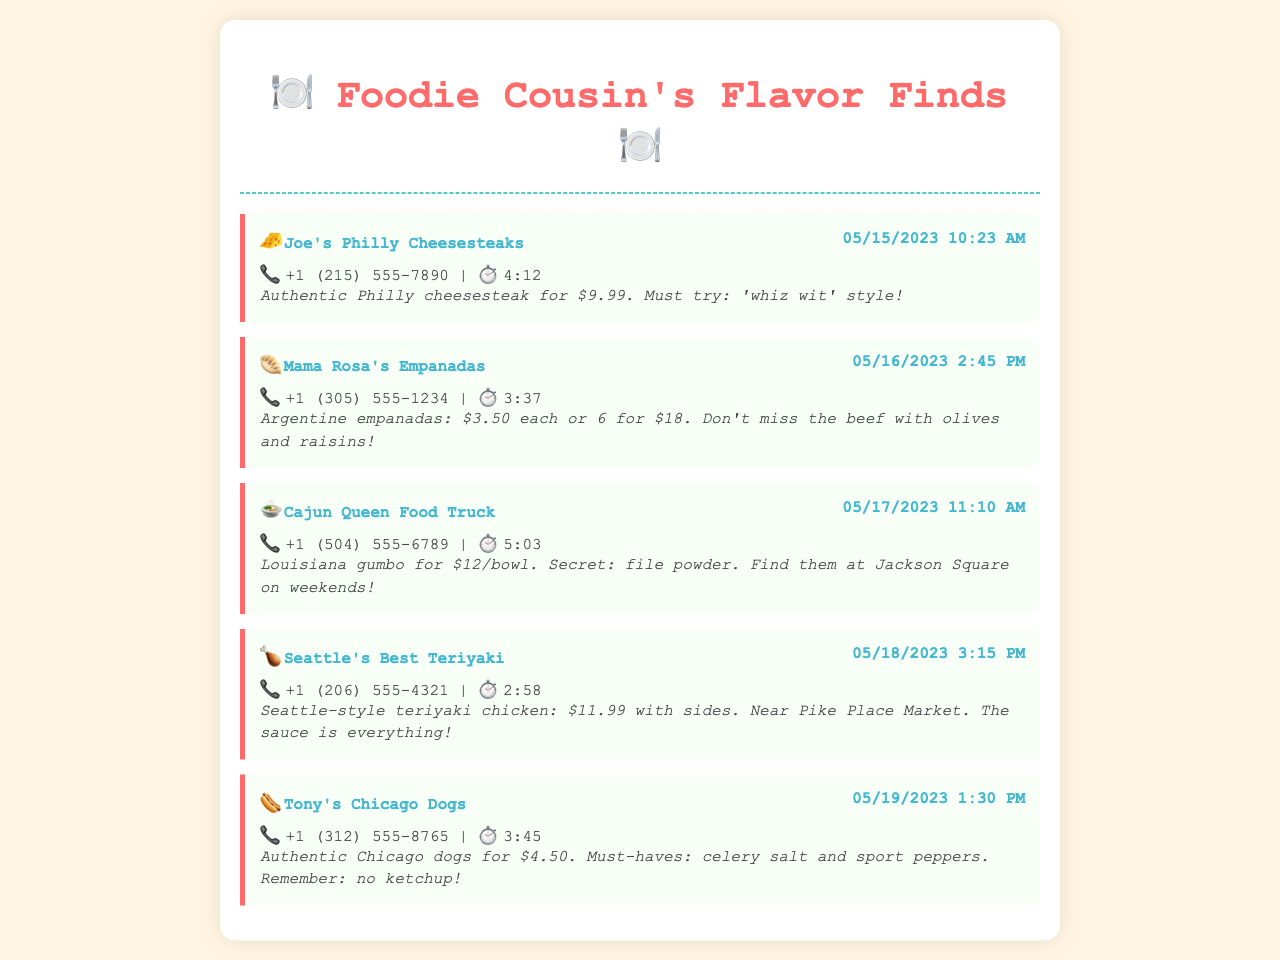What is the phone number for Joe's Philly Cheesesteaks? The phone number is listed beside the vendor in the call log.
Answer: +1 (215) 555-7890 How much do Mama Rosa's empanadas cost each? The price is specified in the call notes of Mama Rosa's Empanadas.
Answer: $3.50 What dish does Cajun Queen Food Truck specialize in? The call notes mention the specialty dish offered by Cajun Queen Food Truck.
Answer: Louisiana gumbo What is the total cost for six empanadas from Mama Rosa's? The total price for six empanadas is derived from the individual price and the offer in the call notes.
Answer: $18 How long was the call with Seattle's Best Teriyaki? The duration of the call is mentioned in the call log under the respective entry.
Answer: 2:58 What is a must-have topping for Tony's Chicago Dogs? The call notes for Tony's Chicago Dogs specify a crucial topping that should be included.
Answer: celery salt Where can you find Cajun Queen Food Truck on weekends? The location is noted in the call entry related to Cajun Queen Food Truck.
Answer: Jackson Square What time did the call with Mama Rosa's Empanadas take place? The call time is provided in the call header for Mama Rosa's Empanadas.
Answer: 2:45 PM 